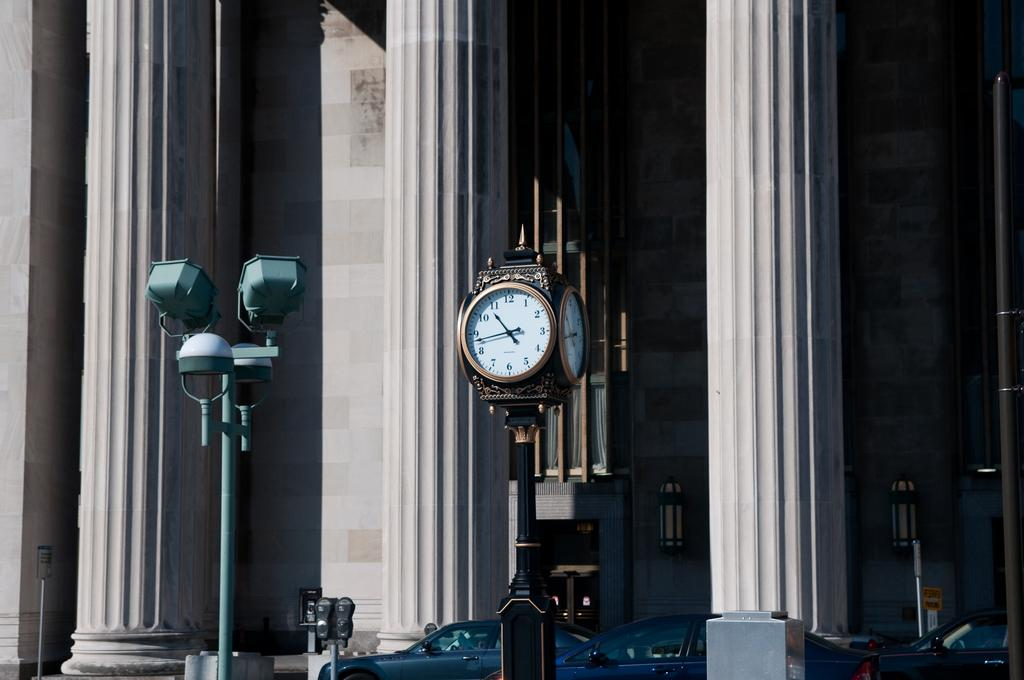<image>
Create a compact narrative representing the image presented. A square clock that says 10:43 is on a post in front of a building with large columns in front. 